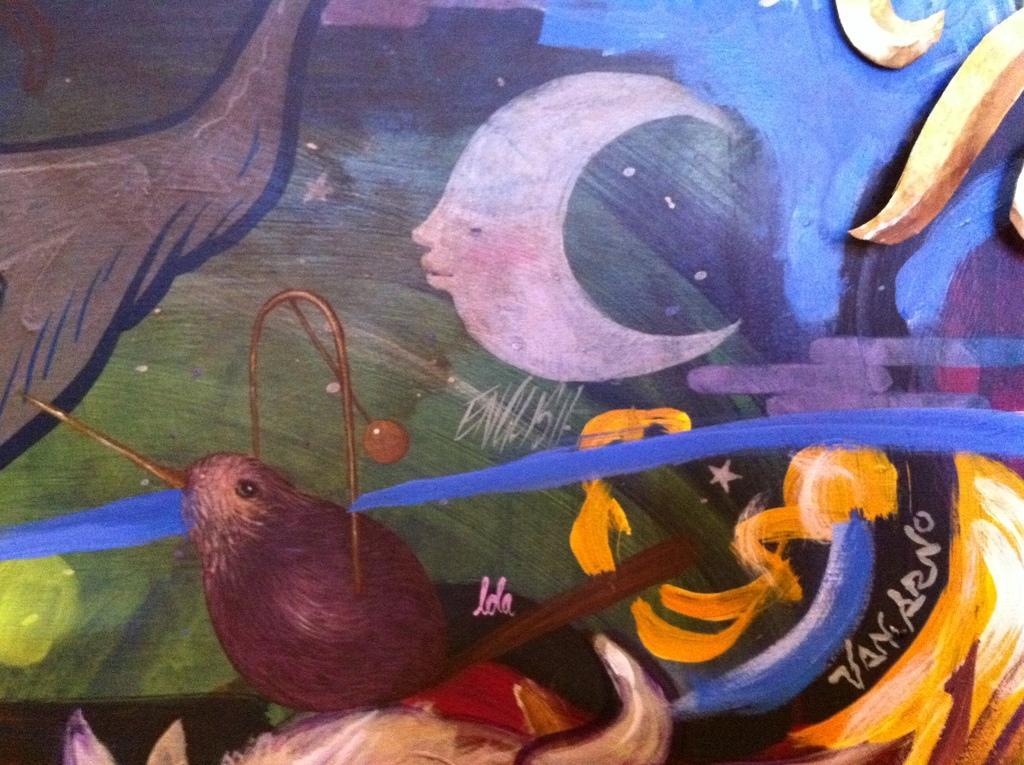How would you summarize this image in a sentence or two? In this picture I can see a painting and words on an object. 